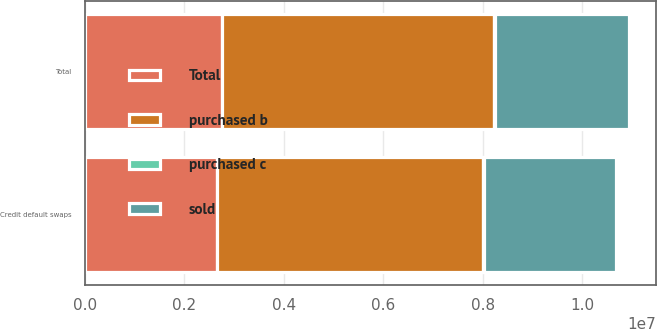<chart> <loc_0><loc_0><loc_500><loc_500><stacked_bar_chart><ecel><fcel>Credit default swaps<fcel>Total<nl><fcel>sold<fcel>2.66166e+06<fcel>2.69591e+06<nl><fcel>Total<fcel>2.65882e+06<fcel>2.7526e+06<nl><fcel>purchased c<fcel>23523<fcel>23523<nl><fcel>purchased b<fcel>5.34442e+06<fcel>5.47245e+06<nl></chart> 